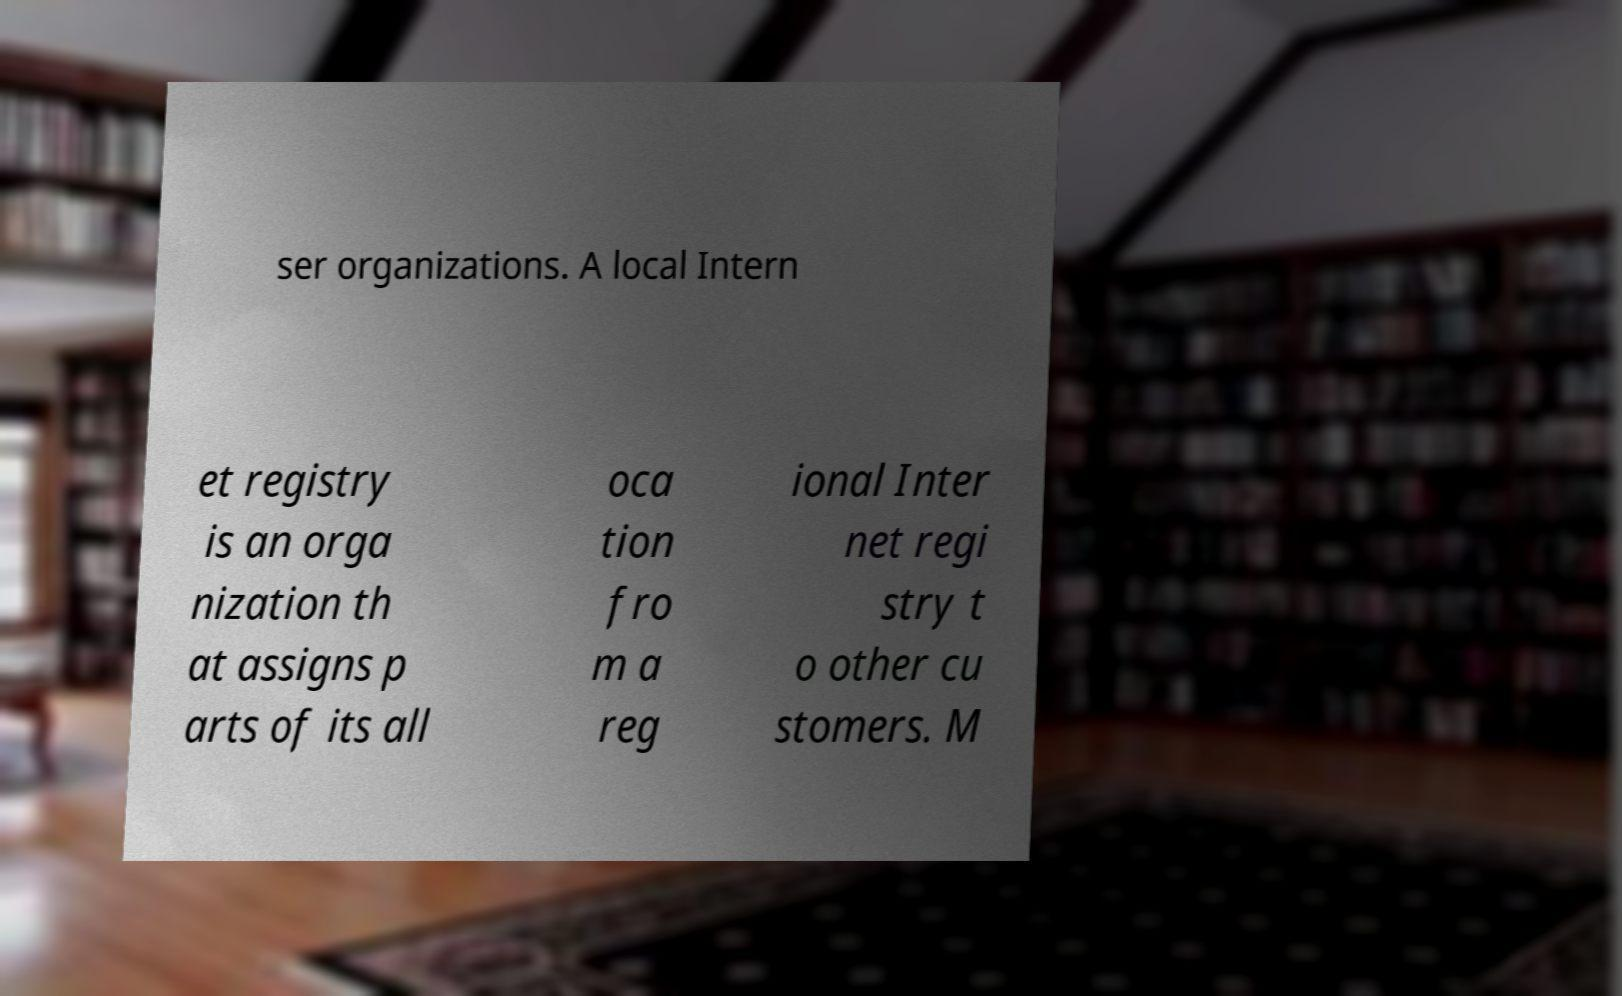Could you extract and type out the text from this image? ser organizations. A local Intern et registry is an orga nization th at assigns p arts of its all oca tion fro m a reg ional Inter net regi stry t o other cu stomers. M 